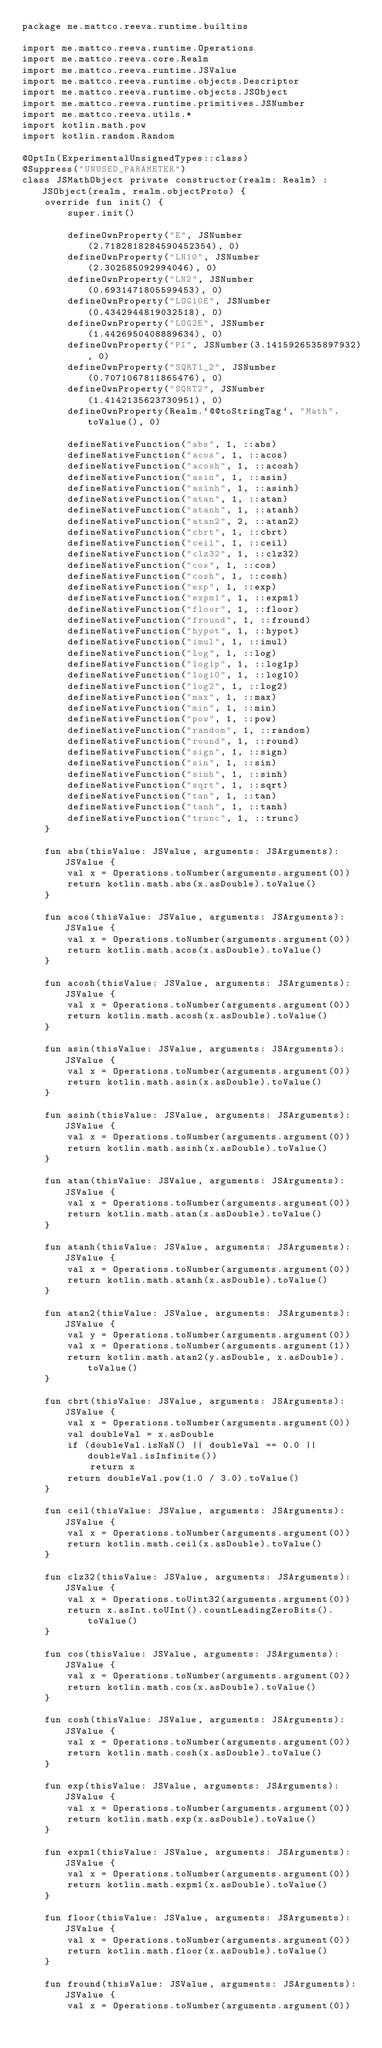<code> <loc_0><loc_0><loc_500><loc_500><_Kotlin_>package me.mattco.reeva.runtime.builtins

import me.mattco.reeva.runtime.Operations
import me.mattco.reeva.core.Realm
import me.mattco.reeva.runtime.JSValue
import me.mattco.reeva.runtime.objects.Descriptor
import me.mattco.reeva.runtime.objects.JSObject
import me.mattco.reeva.runtime.primitives.JSNumber
import me.mattco.reeva.utils.*
import kotlin.math.pow
import kotlin.random.Random

@OptIn(ExperimentalUnsignedTypes::class)
@Suppress("UNUSED_PARAMETER")
class JSMathObject private constructor(realm: Realm) : JSObject(realm, realm.objectProto) {
    override fun init() {
        super.init()

        defineOwnProperty("E", JSNumber(2.7182818284590452354), 0)
        defineOwnProperty("LN10", JSNumber(2.302585092994046), 0)
        defineOwnProperty("LN2", JSNumber(0.6931471805599453), 0)
        defineOwnProperty("LOG10E", JSNumber(0.4342944819032518), 0)
        defineOwnProperty("LOG2E", JSNumber(1.4426950408889634), 0)
        defineOwnProperty("PI", JSNumber(3.1415926535897932), 0)
        defineOwnProperty("SQRT1_2", JSNumber(0.7071067811865476), 0)
        defineOwnProperty("SQRT2", JSNumber(1.4142135623730951), 0)
        defineOwnProperty(Realm.`@@toStringTag`, "Math".toValue(), 0)

        defineNativeFunction("abs", 1, ::abs)
        defineNativeFunction("acos", 1, ::acos)
        defineNativeFunction("acosh", 1, ::acosh)
        defineNativeFunction("asin", 1, ::asin)
        defineNativeFunction("asinh", 1, ::asinh)
        defineNativeFunction("atan", 1, ::atan)
        defineNativeFunction("atanh", 1, ::atanh)
        defineNativeFunction("atan2", 2, ::atan2)
        defineNativeFunction("cbrt", 1, ::cbrt)
        defineNativeFunction("ceil", 1, ::ceil)
        defineNativeFunction("clz32", 1, ::clz32)
        defineNativeFunction("cos", 1, ::cos)
        defineNativeFunction("cosh", 1, ::cosh)
        defineNativeFunction("exp", 1, ::exp)
        defineNativeFunction("expm1", 1, ::expm1)
        defineNativeFunction("floor", 1, ::floor)
        defineNativeFunction("fround", 1, ::fround)
        defineNativeFunction("hypot", 1, ::hypot)
        defineNativeFunction("imul", 1, ::imul)
        defineNativeFunction("log", 1, ::log)
        defineNativeFunction("log1p", 1, ::log1p)
        defineNativeFunction("log10", 1, ::log10)
        defineNativeFunction("log2", 1, ::log2)
        defineNativeFunction("max", 1, ::max)
        defineNativeFunction("min", 1, ::min)
        defineNativeFunction("pow", 1, ::pow)
        defineNativeFunction("random", 1, ::random)
        defineNativeFunction("round", 1, ::round)
        defineNativeFunction("sign", 1, ::sign)
        defineNativeFunction("sin", 1, ::sin)
        defineNativeFunction("sinh", 1, ::sinh)
        defineNativeFunction("sqrt", 1, ::sqrt)
        defineNativeFunction("tan", 1, ::tan)
        defineNativeFunction("tanh", 1, ::tanh)
        defineNativeFunction("trunc", 1, ::trunc)
    }

    fun abs(thisValue: JSValue, arguments: JSArguments): JSValue {
        val x = Operations.toNumber(arguments.argument(0))
        return kotlin.math.abs(x.asDouble).toValue()
    }

    fun acos(thisValue: JSValue, arguments: JSArguments): JSValue {
        val x = Operations.toNumber(arguments.argument(0))
        return kotlin.math.acos(x.asDouble).toValue()
    }

    fun acosh(thisValue: JSValue, arguments: JSArguments): JSValue {
        val x = Operations.toNumber(arguments.argument(0))
        return kotlin.math.acosh(x.asDouble).toValue()
    }

    fun asin(thisValue: JSValue, arguments: JSArguments): JSValue {
        val x = Operations.toNumber(arguments.argument(0))
        return kotlin.math.asin(x.asDouble).toValue()
    }

    fun asinh(thisValue: JSValue, arguments: JSArguments): JSValue {
        val x = Operations.toNumber(arguments.argument(0))
        return kotlin.math.asinh(x.asDouble).toValue()
    }

    fun atan(thisValue: JSValue, arguments: JSArguments): JSValue {
        val x = Operations.toNumber(arguments.argument(0))
        return kotlin.math.atan(x.asDouble).toValue()
    }

    fun atanh(thisValue: JSValue, arguments: JSArguments): JSValue {
        val x = Operations.toNumber(arguments.argument(0))
        return kotlin.math.atanh(x.asDouble).toValue()
    }

    fun atan2(thisValue: JSValue, arguments: JSArguments): JSValue {
        val y = Operations.toNumber(arguments.argument(0))
        val x = Operations.toNumber(arguments.argument(1))
        return kotlin.math.atan2(y.asDouble, x.asDouble).toValue()
    }

    fun cbrt(thisValue: JSValue, arguments: JSArguments): JSValue {
        val x = Operations.toNumber(arguments.argument(0))
        val doubleVal = x.asDouble
        if (doubleVal.isNaN() || doubleVal == 0.0 || doubleVal.isInfinite())
            return x
        return doubleVal.pow(1.0 / 3.0).toValue()
    }

    fun ceil(thisValue: JSValue, arguments: JSArguments): JSValue {
        val x = Operations.toNumber(arguments.argument(0))
        return kotlin.math.ceil(x.asDouble).toValue()
    }

    fun clz32(thisValue: JSValue, arguments: JSArguments): JSValue {
        val x = Operations.toUint32(arguments.argument(0))
        return x.asInt.toUInt().countLeadingZeroBits().toValue()
    }

    fun cos(thisValue: JSValue, arguments: JSArguments): JSValue {
        val x = Operations.toNumber(arguments.argument(0))
        return kotlin.math.cos(x.asDouble).toValue()
    }

    fun cosh(thisValue: JSValue, arguments: JSArguments): JSValue {
        val x = Operations.toNumber(arguments.argument(0))
        return kotlin.math.cosh(x.asDouble).toValue()
    }

    fun exp(thisValue: JSValue, arguments: JSArguments): JSValue {
        val x = Operations.toNumber(arguments.argument(0))
        return kotlin.math.exp(x.asDouble).toValue()
    }

    fun expm1(thisValue: JSValue, arguments: JSArguments): JSValue {
        val x = Operations.toNumber(arguments.argument(0))
        return kotlin.math.expm1(x.asDouble).toValue()
    }

    fun floor(thisValue: JSValue, arguments: JSArguments): JSValue {
        val x = Operations.toNumber(arguments.argument(0))
        return kotlin.math.floor(x.asDouble).toValue()
    }

    fun fround(thisValue: JSValue, arguments: JSArguments): JSValue {
        val x = Operations.toNumber(arguments.argument(0))</code> 